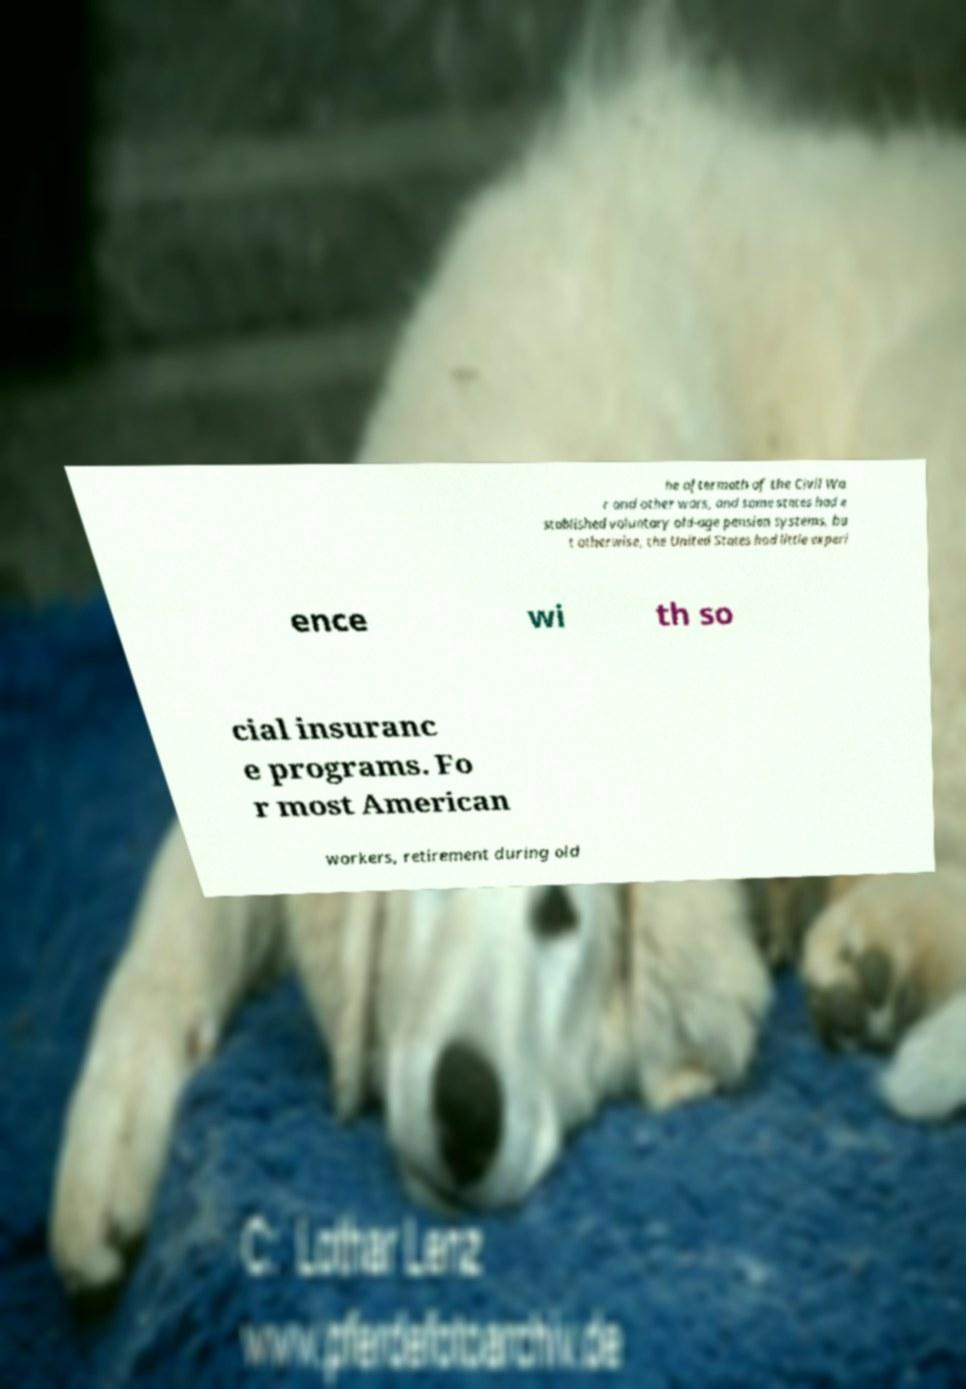Can you read and provide the text displayed in the image?This photo seems to have some interesting text. Can you extract and type it out for me? he aftermath of the Civil Wa r and other wars, and some states had e stablished voluntary old-age pension systems, bu t otherwise, the United States had little experi ence wi th so cial insuranc e programs. Fo r most American workers, retirement during old 